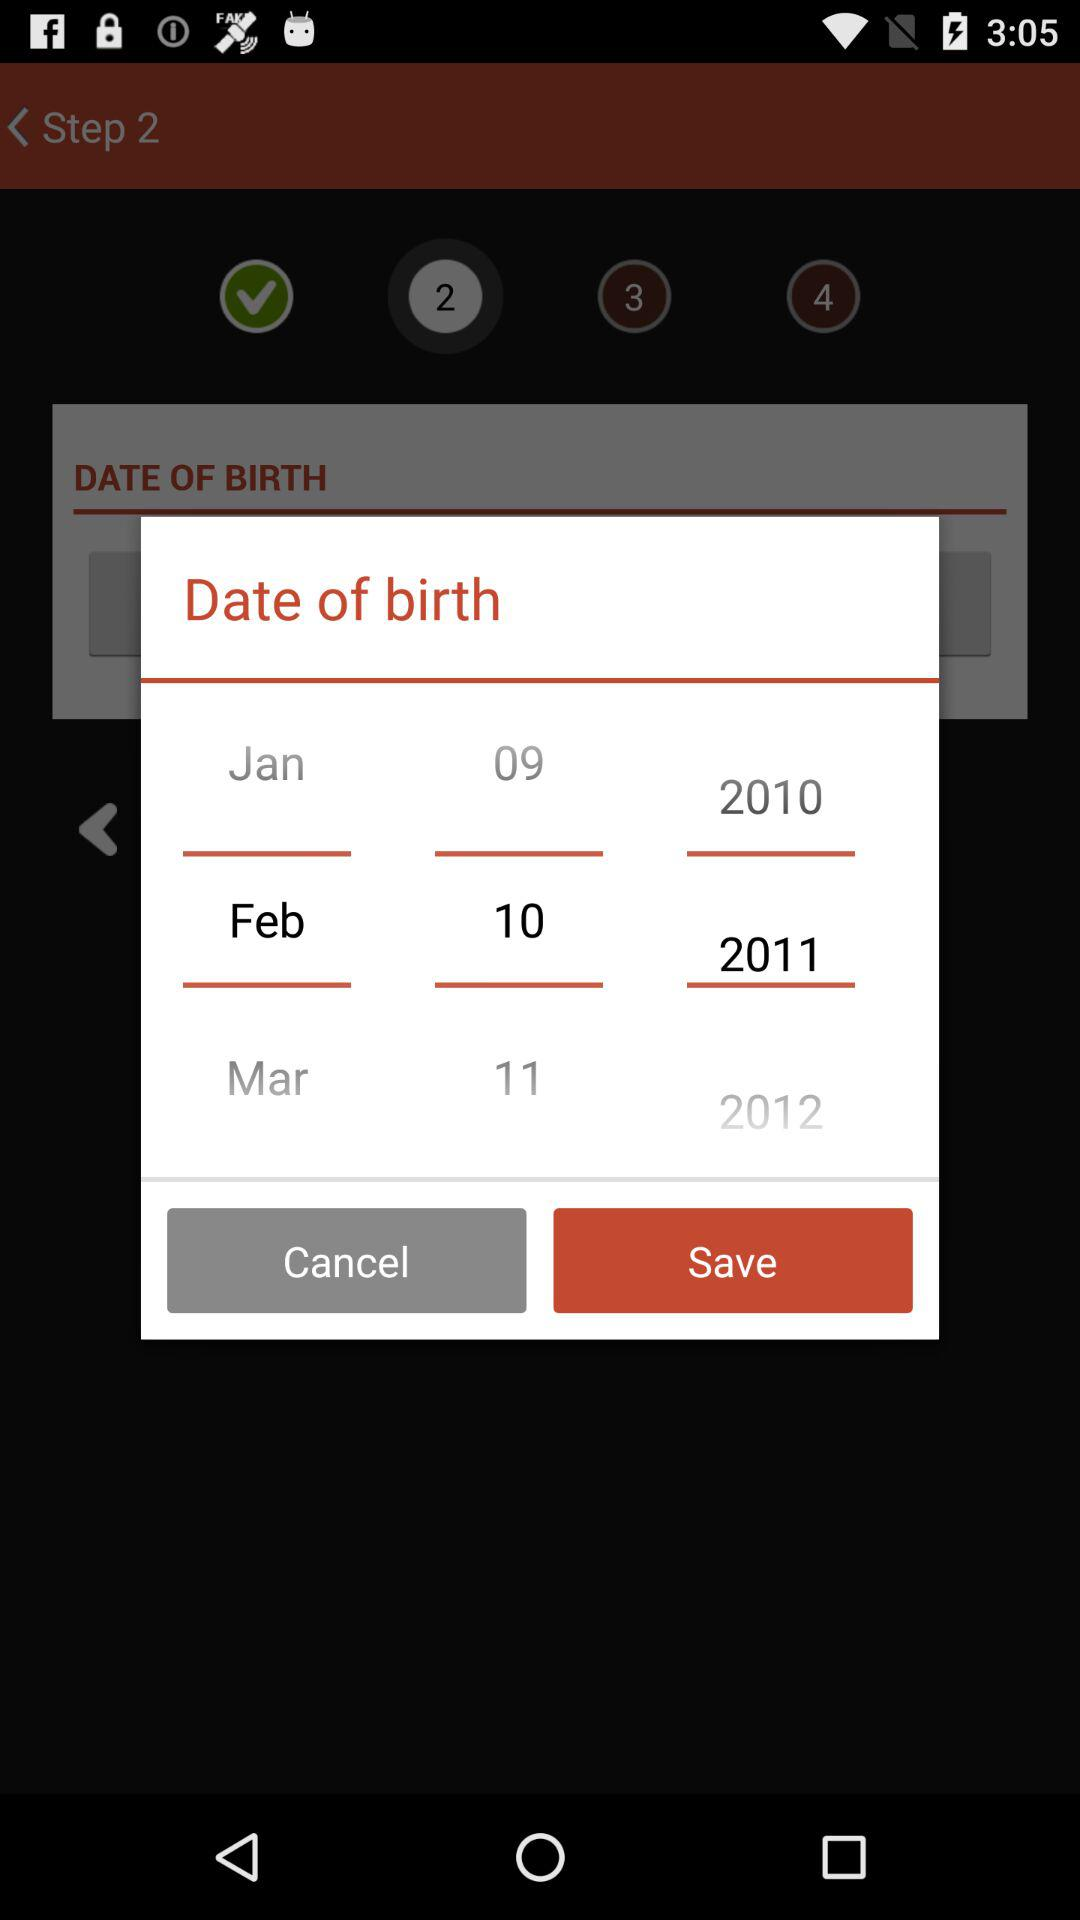What is the selected date? The selected date is February 10, 2011. 